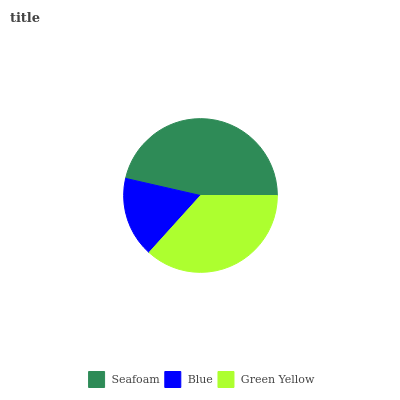Is Blue the minimum?
Answer yes or no. Yes. Is Seafoam the maximum?
Answer yes or no. Yes. Is Green Yellow the minimum?
Answer yes or no. No. Is Green Yellow the maximum?
Answer yes or no. No. Is Green Yellow greater than Blue?
Answer yes or no. Yes. Is Blue less than Green Yellow?
Answer yes or no. Yes. Is Blue greater than Green Yellow?
Answer yes or no. No. Is Green Yellow less than Blue?
Answer yes or no. No. Is Green Yellow the high median?
Answer yes or no. Yes. Is Green Yellow the low median?
Answer yes or no. Yes. Is Seafoam the high median?
Answer yes or no. No. Is Blue the low median?
Answer yes or no. No. 